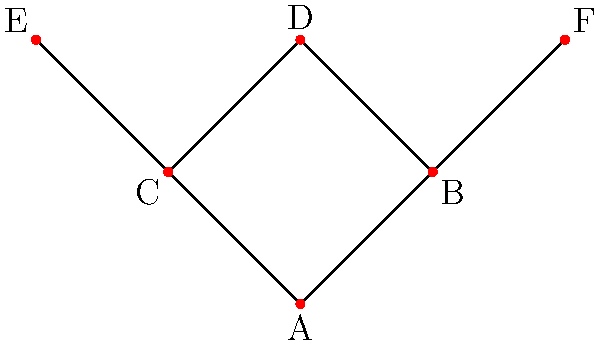In the context of an ancestral family tree structure, consider the diagram above representing a partial family tree. If we define a group operation ∘ such that X ∘ Y represents the most recent common ancestor of individuals X and Y, which of the following statements is true about the group properties of this structure?

a) The operation ∘ is associative for all elements
b) There exists an identity element for the operation ∘
c) Every element has an inverse under the operation ∘
d) The operation ∘ is commutative for all elements Let's analyze each property step by step:

1. Associativity: (X ∘ Y) ∘ Z = X ∘ (Y ∘ Z)
   This holds true. For example, (B ∘ C) ∘ F = A ∘ F = A, and B ∘ (C ∘ F) = B ∘ A = A

2. Identity element:
   There is no single element that, when combined with any other element, always returns that other element. The closest would be A, but A ∘ X = A for all X, not X.

3. Inverse elements:
   For any element X, there is no element Y such that X ∘ Y = identity element (since there is no identity element).

4. Commutativity: X ∘ Y = Y ∘ X
   This property holds true. The most recent common ancestor of X and Y is the same regardless of the order.

Therefore, the only property that holds true for all elements in this structure is commutativity.
Answer: d 